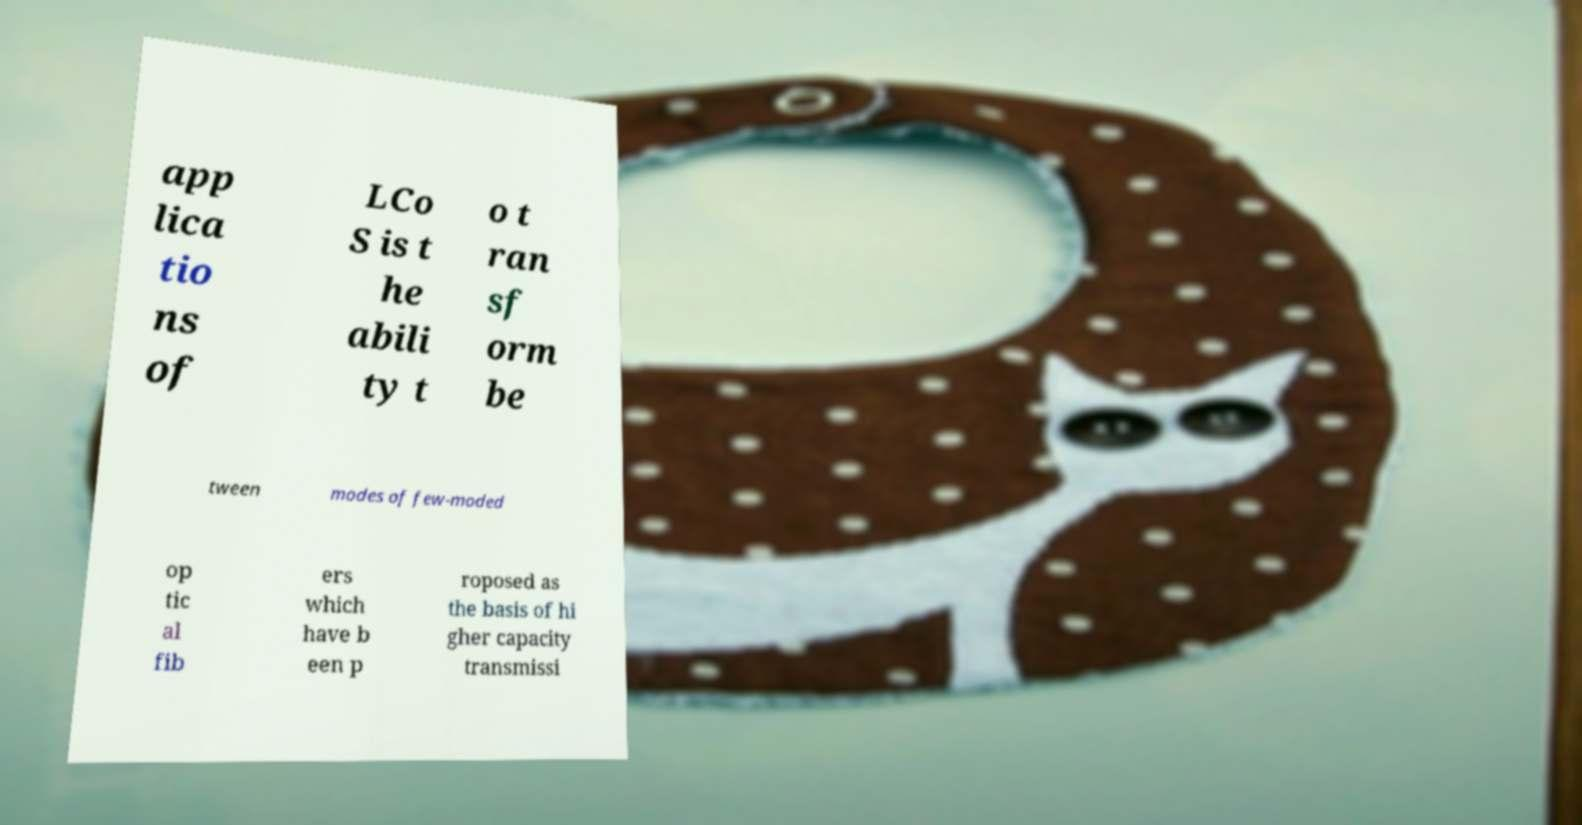Can you read and provide the text displayed in the image?This photo seems to have some interesting text. Can you extract and type it out for me? app lica tio ns of LCo S is t he abili ty t o t ran sf orm be tween modes of few-moded op tic al fib ers which have b een p roposed as the basis of hi gher capacity transmissi 